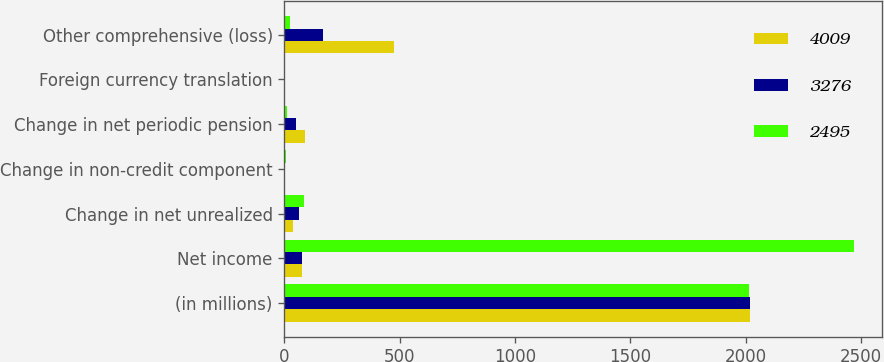<chart> <loc_0><loc_0><loc_500><loc_500><stacked_bar_chart><ecel><fcel>(in millions)<fcel>Net income<fcel>Change in net unrealized<fcel>Change in non-credit component<fcel>Change in net periodic pension<fcel>Foreign currency translation<fcel>Other comprehensive (loss)<nl><fcel>4009<fcel>2018<fcel>76<fcel>37<fcel>2<fcel>90<fcel>1<fcel>474<nl><fcel>3276<fcel>2017<fcel>76<fcel>65<fcel>4<fcel>51<fcel>3<fcel>166<nl><fcel>2495<fcel>2016<fcel>2470<fcel>87<fcel>5<fcel>13<fcel>2<fcel>25<nl></chart> 